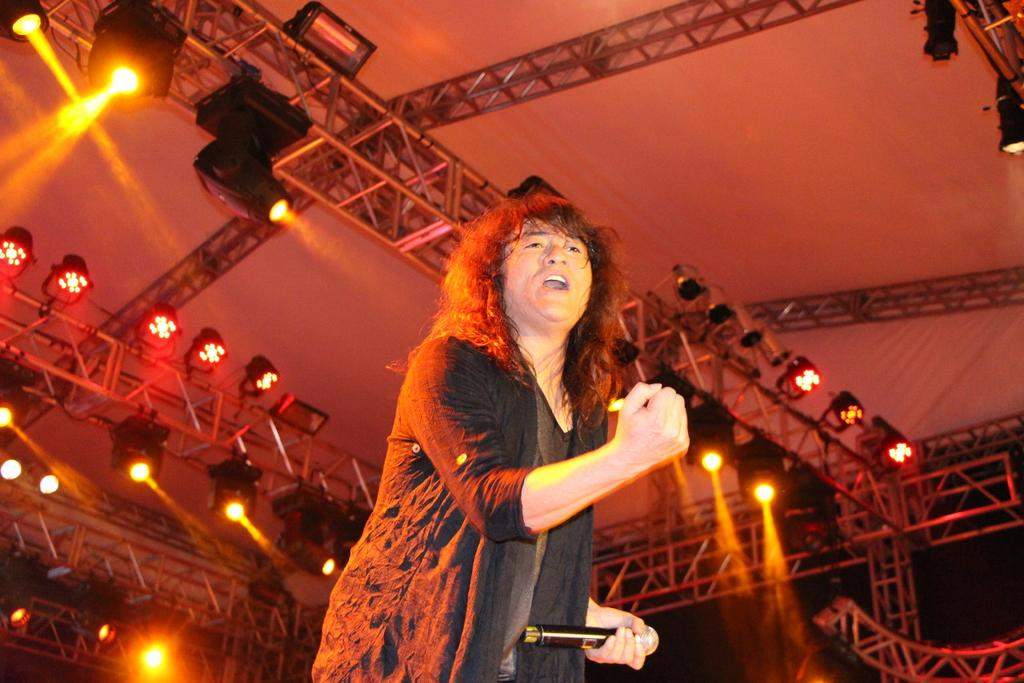What is the main subject of the image? There is a person standing in the center of the image. What is the person holding in the image? The person is holding a mic. What can be seen in the background of the image? There is a roof with metal frames visible in the background. Are there any lights visible in the image? Yes, some ceiling lights are present on the roof. Reasoning: Let'g: Let's think step by step in order to produce the conversation. We start by identifying the main subject of the image, which is the person standing in the center. Then, we describe what the person is holding, which is a mic. Next, we mention the background of the image, which includes a roof with metal frames. Finally, we acknowledge the presence of lights on the roof. Absurd Question/Answer: Can you see any visible veins on the person's hand in the image? There is no information about the person's hand or veins in the image, so we cannot determine if they are visible. Is there a faucet present in the image? No, there is no faucet visible in the image. Is there a calculator visible on the roof in the image? No, there is no calculator visible on the roof in the image. 